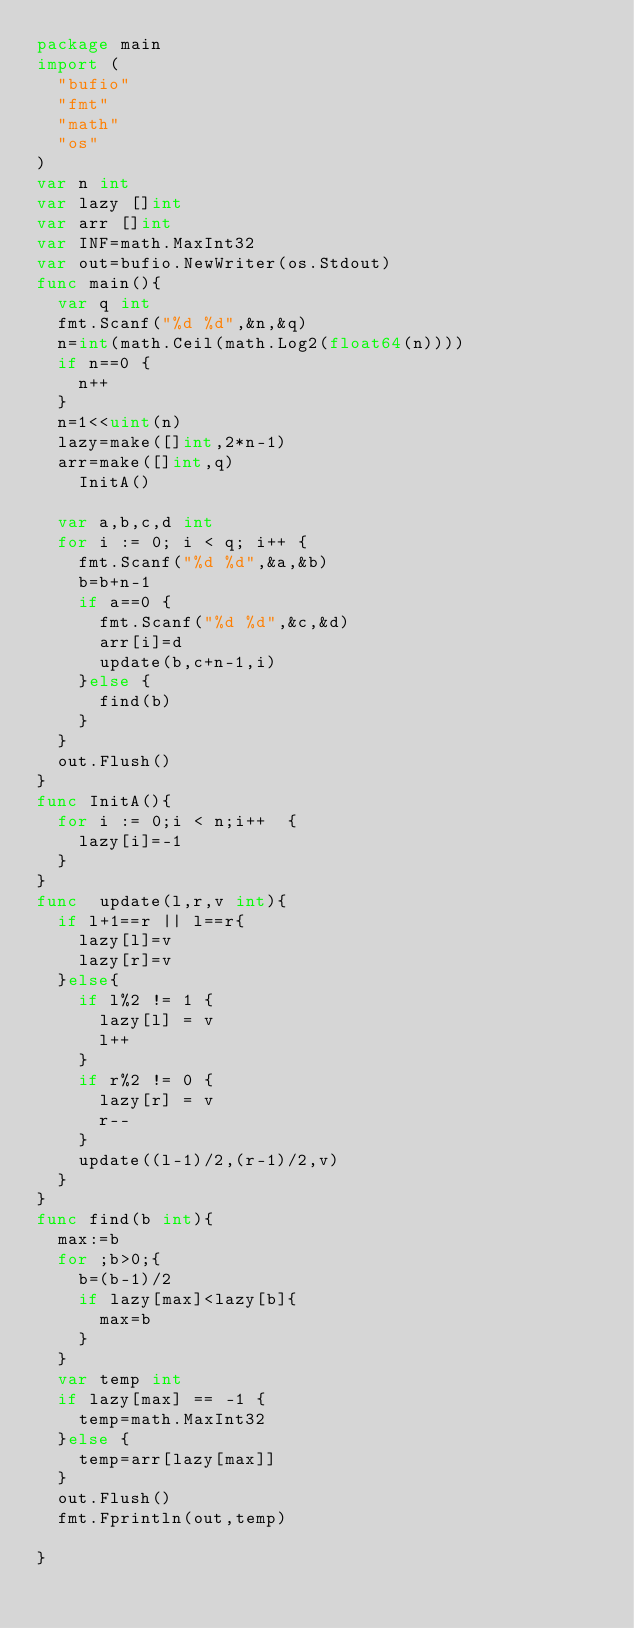<code> <loc_0><loc_0><loc_500><loc_500><_Go_>package main
import (
	"bufio"
	"fmt"
	"math"
	"os"
)
var n int
var lazy []int
var arr []int
var INF=math.MaxInt32
var out=bufio.NewWriter(os.Stdout)
func main(){
	var q int
	fmt.Scanf("%d %d",&n,&q)
	n=int(math.Ceil(math.Log2(float64(n))))
	if n==0 {
		n++
	}
	n=1<<uint(n)
	lazy=make([]int,2*n-1)
	arr=make([]int,q)
    InitA()

	var a,b,c,d int
	for i := 0; i < q; i++ {
		fmt.Scanf("%d %d",&a,&b)
		b=b+n-1
		if a==0 {
			fmt.Scanf("%d %d",&c,&d)
			arr[i]=d
			update(b,c+n-1,i)
		}else {
			find(b)
		}
	}
	out.Flush()
}
func InitA(){
	for i := 0;i < n;i++  {
		lazy[i]=-1
	}
}
func  update(l,r,v int){
	if l+1==r || l==r{
		lazy[l]=v
		lazy[r]=v
	}else{
		if l%2 != 1 {
			lazy[l] = v
			l++
		}
		if r%2 != 0 {
			lazy[r] = v
			r--
		}
		update((l-1)/2,(r-1)/2,v)
	}
}
func find(b int){
	max:=b
	for ;b>0;{
		b=(b-1)/2
		if lazy[max]<lazy[b]{
			max=b
		}
	}
	var temp int
	if lazy[max] == -1 {
		temp=math.MaxInt32
	}else {
		temp=arr[lazy[max]]
	}
	out.Flush()
	fmt.Fprintln(out,temp)

}

</code> 